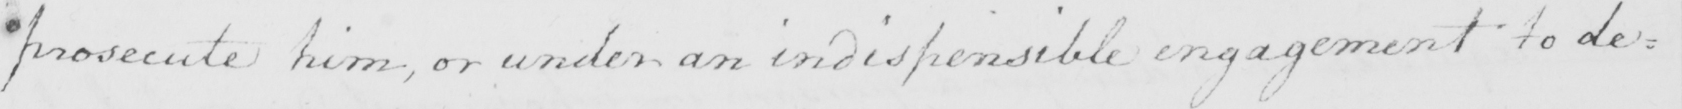Can you tell me what this handwritten text says? prosecute him , or under an indispensible engagement to de : 